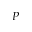Convert formula to latex. <formula><loc_0><loc_0><loc_500><loc_500>P</formula> 